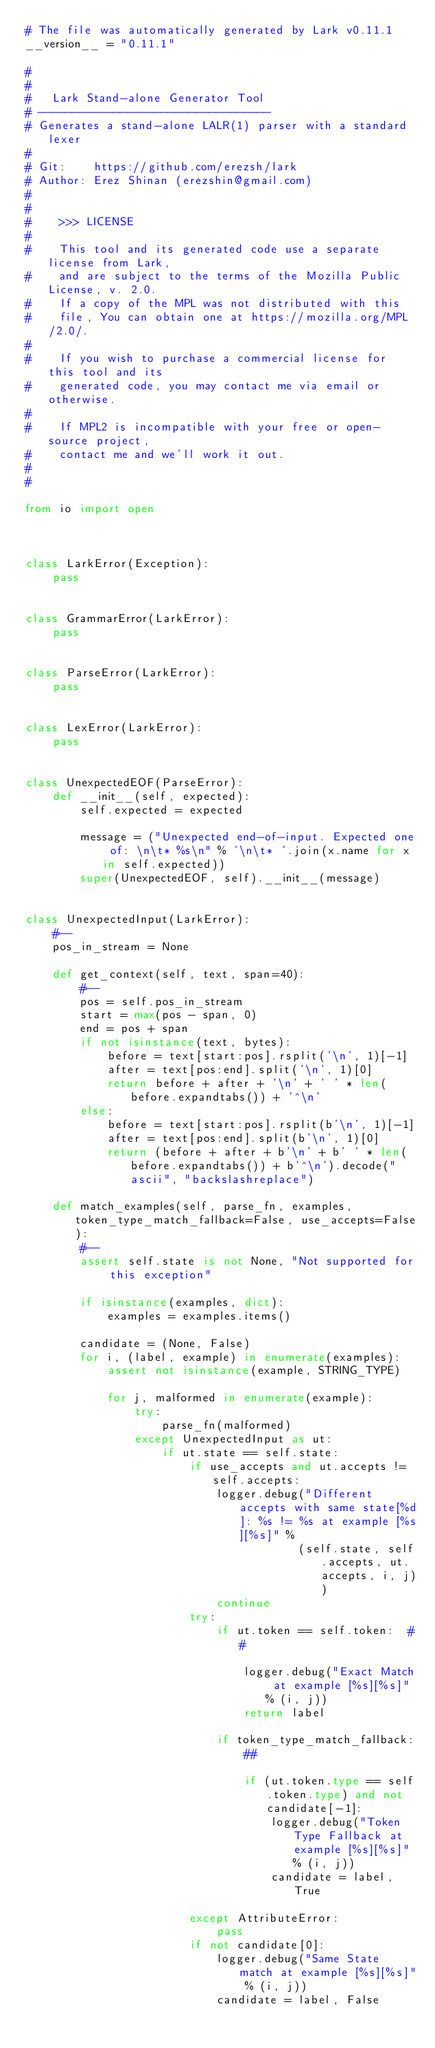Convert code to text. <code><loc_0><loc_0><loc_500><loc_500><_Python_># The file was automatically generated by Lark v0.11.1
__version__ = "0.11.1"

#
#
#   Lark Stand-alone Generator Tool
# ----------------------------------
# Generates a stand-alone LALR(1) parser with a standard lexer
#
# Git:    https://github.com/erezsh/lark
# Author: Erez Shinan (erezshin@gmail.com)
#
#
#    >>> LICENSE
#
#    This tool and its generated code use a separate license from Lark,
#    and are subject to the terms of the Mozilla Public License, v. 2.0.
#    If a copy of the MPL was not distributed with this
#    file, You can obtain one at https://mozilla.org/MPL/2.0/.
#
#    If you wish to purchase a commercial license for this tool and its
#    generated code, you may contact me via email or otherwise.
#
#    If MPL2 is incompatible with your free or open-source project,
#    contact me and we'll work it out.
#
#

from io import open



class LarkError(Exception):
    pass


class GrammarError(LarkError):
    pass


class ParseError(LarkError):
    pass


class LexError(LarkError):
    pass


class UnexpectedEOF(ParseError):
    def __init__(self, expected):
        self.expected = expected

        message = ("Unexpected end-of-input. Expected one of: \n\t* %s\n" % '\n\t* '.join(x.name for x in self.expected))
        super(UnexpectedEOF, self).__init__(message)


class UnexpectedInput(LarkError):
    #--
    pos_in_stream = None

    def get_context(self, text, span=40):
        #--
        pos = self.pos_in_stream
        start = max(pos - span, 0)
        end = pos + span
        if not isinstance(text, bytes):
            before = text[start:pos].rsplit('\n', 1)[-1]
            after = text[pos:end].split('\n', 1)[0]
            return before + after + '\n' + ' ' * len(before.expandtabs()) + '^\n'
        else:
            before = text[start:pos].rsplit(b'\n', 1)[-1]
            after = text[pos:end].split(b'\n', 1)[0]
            return (before + after + b'\n' + b' ' * len(before.expandtabs()) + b'^\n').decode("ascii", "backslashreplace")

    def match_examples(self, parse_fn, examples, token_type_match_fallback=False, use_accepts=False):
        #--
        assert self.state is not None, "Not supported for this exception"

        if isinstance(examples, dict):
            examples = examples.items()

        candidate = (None, False)
        for i, (label, example) in enumerate(examples):
            assert not isinstance(example, STRING_TYPE)

            for j, malformed in enumerate(example):
                try:
                    parse_fn(malformed)
                except UnexpectedInput as ut:
                    if ut.state == self.state:
                        if use_accepts and ut.accepts != self.accepts:
                            logger.debug("Different accepts with same state[%d]: %s != %s at example [%s][%s]" %
                                        (self.state, self.accepts, ut.accepts, i, j))
                            continue
                        try:
                            if ut.token == self.token:  ##

                                logger.debug("Exact Match at example [%s][%s]" % (i, j))
                                return label

                            if token_type_match_fallback:
                                ##

                                if (ut.token.type == self.token.type) and not candidate[-1]:
                                    logger.debug("Token Type Fallback at example [%s][%s]" % (i, j))
                                    candidate = label, True

                        except AttributeError:
                            pass
                        if not candidate[0]:
                            logger.debug("Same State match at example [%s][%s]" % (i, j))
                            candidate = label, False
</code> 